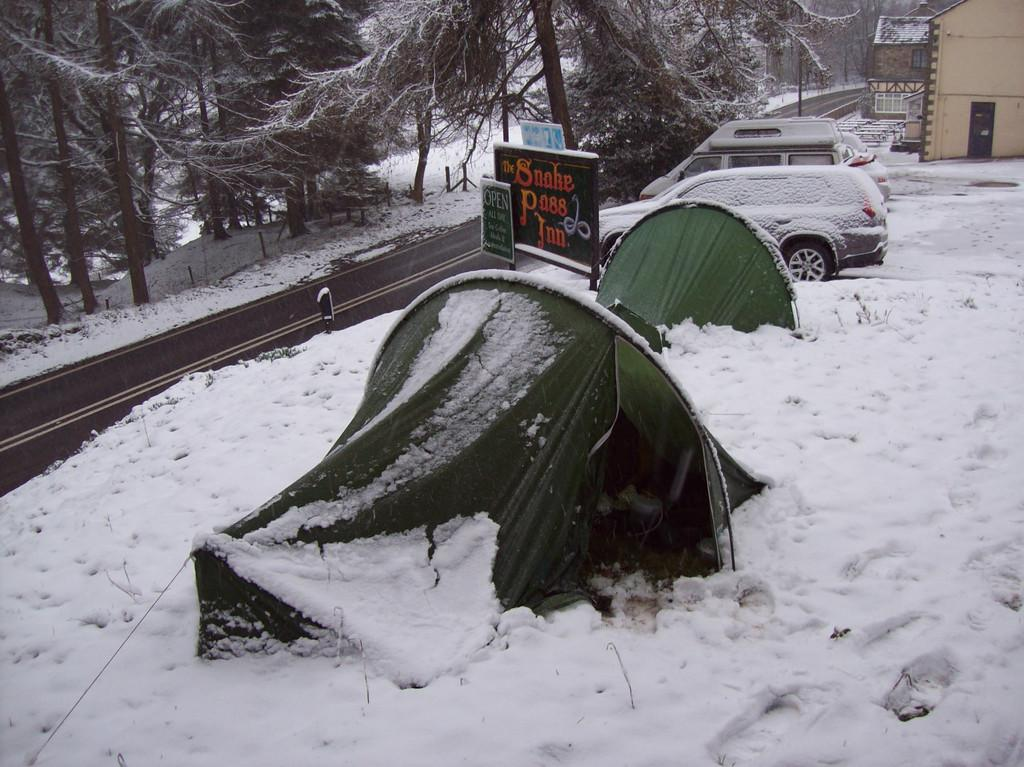<image>
Provide a brief description of the given image. The side of the road is snow covered, as well as the parking lot past the sign for the Snake Pass Inn. 